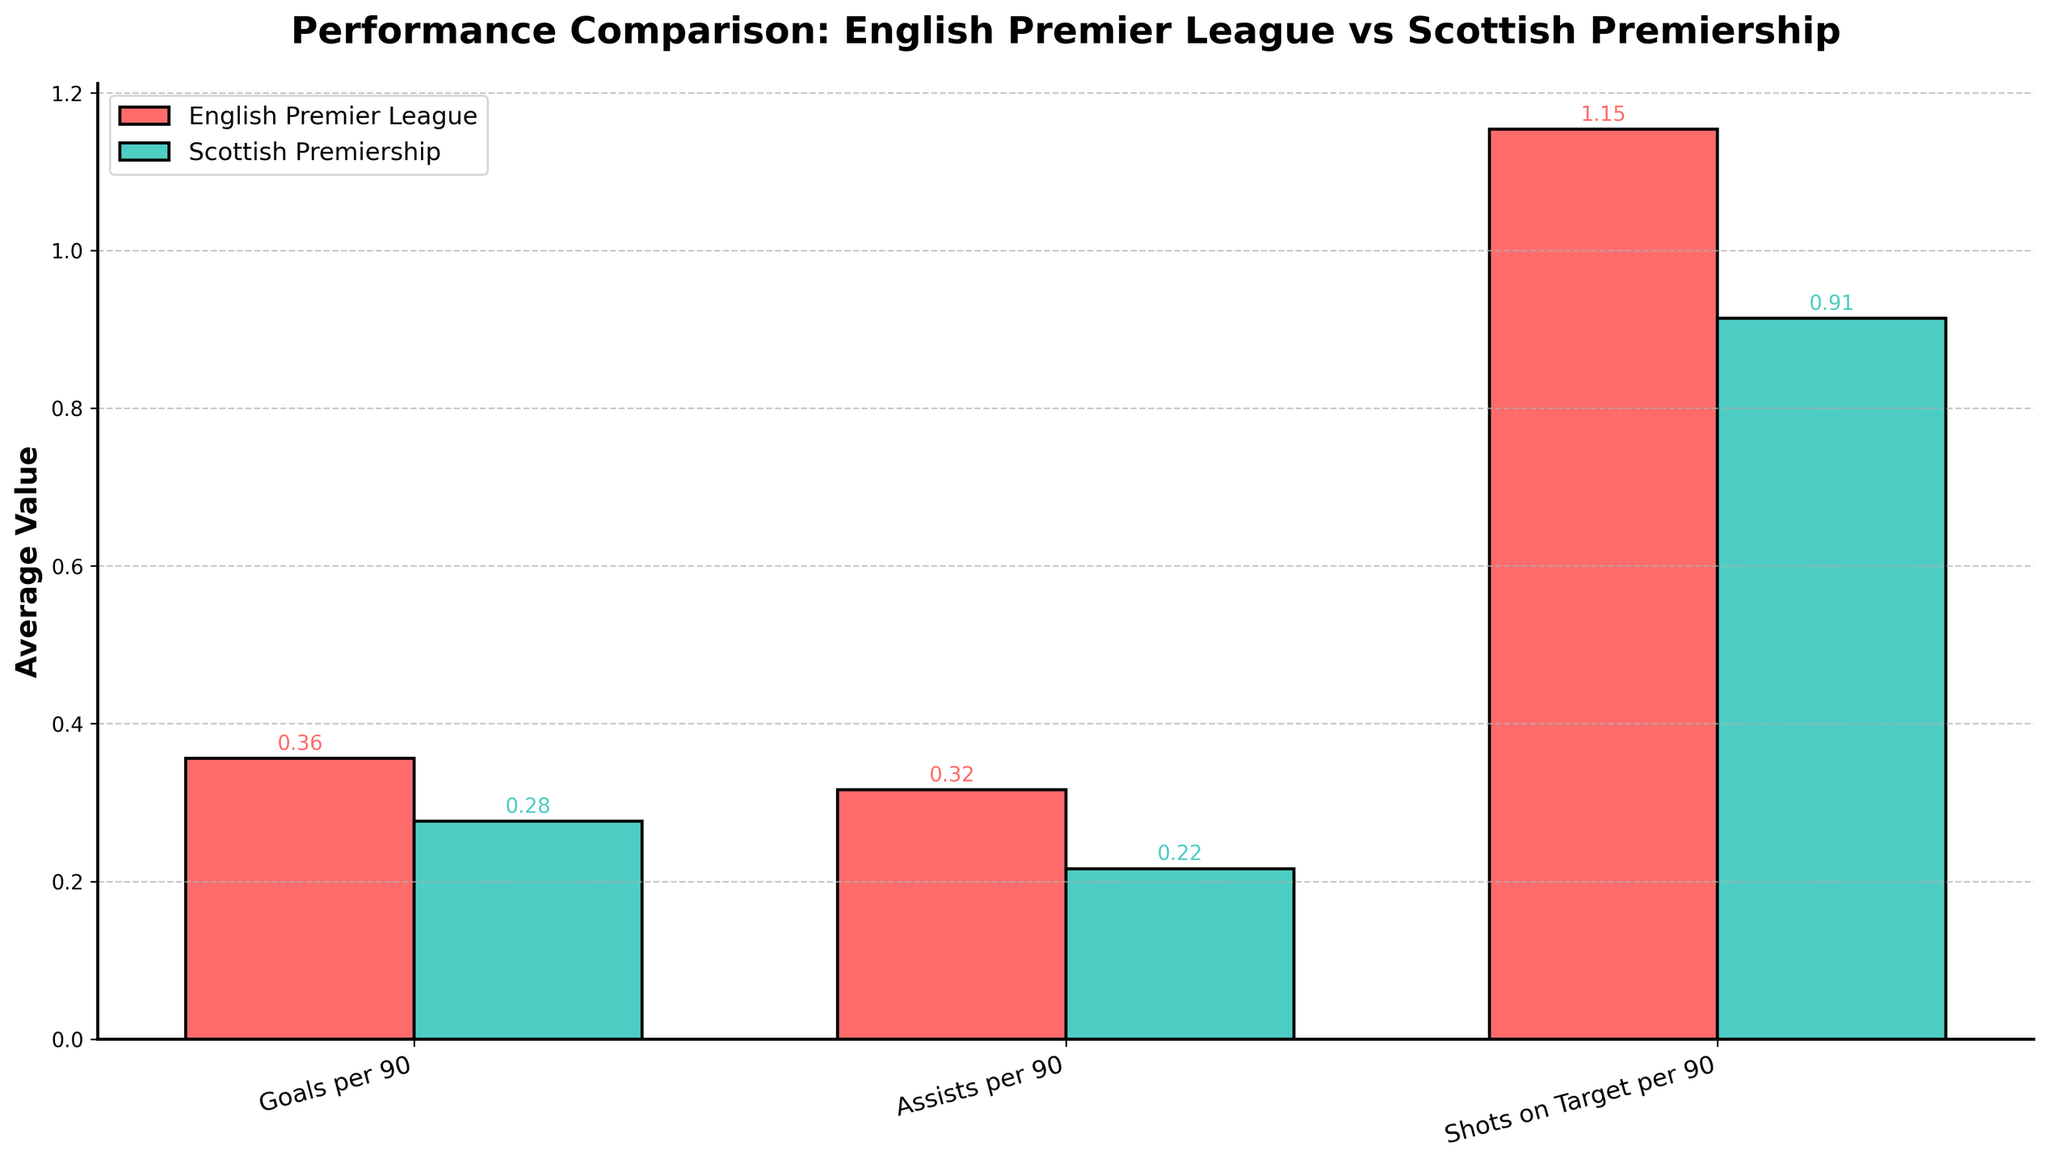What is the average number of goals per 90 minutes for English players in the English Premier League and Scottish Premiership? To find the average goals per 90 minutes for players, look at the heights of the bars in the "Goals per 90" category for each league. Calculate the mean by summing up the individual goals per 90 figures for players in each league and dividing by the number of players. For English Premier League: (0.68 + 0.45 + 0.26 + 0.32 + 0.07) / 5. For Scottish Premiership: (0.52 + 0.41 + 0.22 + 0.18 + 0.05) / 5.
Answer: English Premier League: 0.36, Scottish Premiership: 0.28 Are assists per 90 minutes higher in the English Premier League or Scottish Premiership? Compare the height of the bars in the "Assists per 90" category between the two leagues. The league with the taller bar represents higher assists per 90 minutes on average.
Answer: Scottish Premiership Which league has a higher average number of shots on target per 90 minutes? To determine this, compare the height of the bars in the "Shots on Target per 90" category for both leagues. The league with the taller bar has a higher average number of shots on target per 90 minutes.
Answer: English Premier League What is the difference in average pass completion percentage between the two leagues? Calculate the pass completion percentage for each league by first determining the values from the data and then finding the difference. Sum the pass completion percentages for all players within each league and divide by the number of players. English Premier League: (71.3 + 85.2 + 88.1 + 84.6 + 77.8) / 5. Scottish Premiership: (68.7 + 78.9 + 82.4 + 89.3 + 84.5) / 5. Then, find the difference between the two averages.
Answer: 81.4 - 80.76 = 0.64 Which league has the highest average value for any of the three metrics? Compare the average values for "Goals per 90", "Assists per 90", and "Shots on Target per 90" across both leagues. The highest value among these averages will indicate the league and metric it corresponds to.
Answer: English Premier League for Shots on Target per 90 How much higher is the average value of goals per 90 minutes in the English Premier League compared to the Scottish Premiership? Find the average goals per 90 minutes for each league and then calculate the difference. Average goals for English Premier League: 0.36, Scottish Premiership: 0.28. Then, calculate the difference: 0.36 - 0.28.
Answer: 0.08 Which metric shows the greatest difference in averages between the two leagues? Calculate the average value of each metric for both leagues. Then, find the absolute difference for each metric between the leagues. The metric with the highest difference is the one that shows the greatest difference.
Answer: Goals per 90 Is there any metric where the Scottish Premiership outperforms the English Premier League? Compare each metric (Goals per 90, Assists per 90, Shots on Target per 90) across the two leagues. Look for any metric where the average value for the Scottish Premiership is higher than that for the English Premier League.
Answer: Assists per 90 For which metric is the variance between leagues smallest? Calculate the variance for each metric by comparing the spread of values between the leagues. This involves determining how much each league's values differ from the mean for that metric. The metric with the smallest difference between leagues will have the smallest variance.
Answer: Pass Completion % 